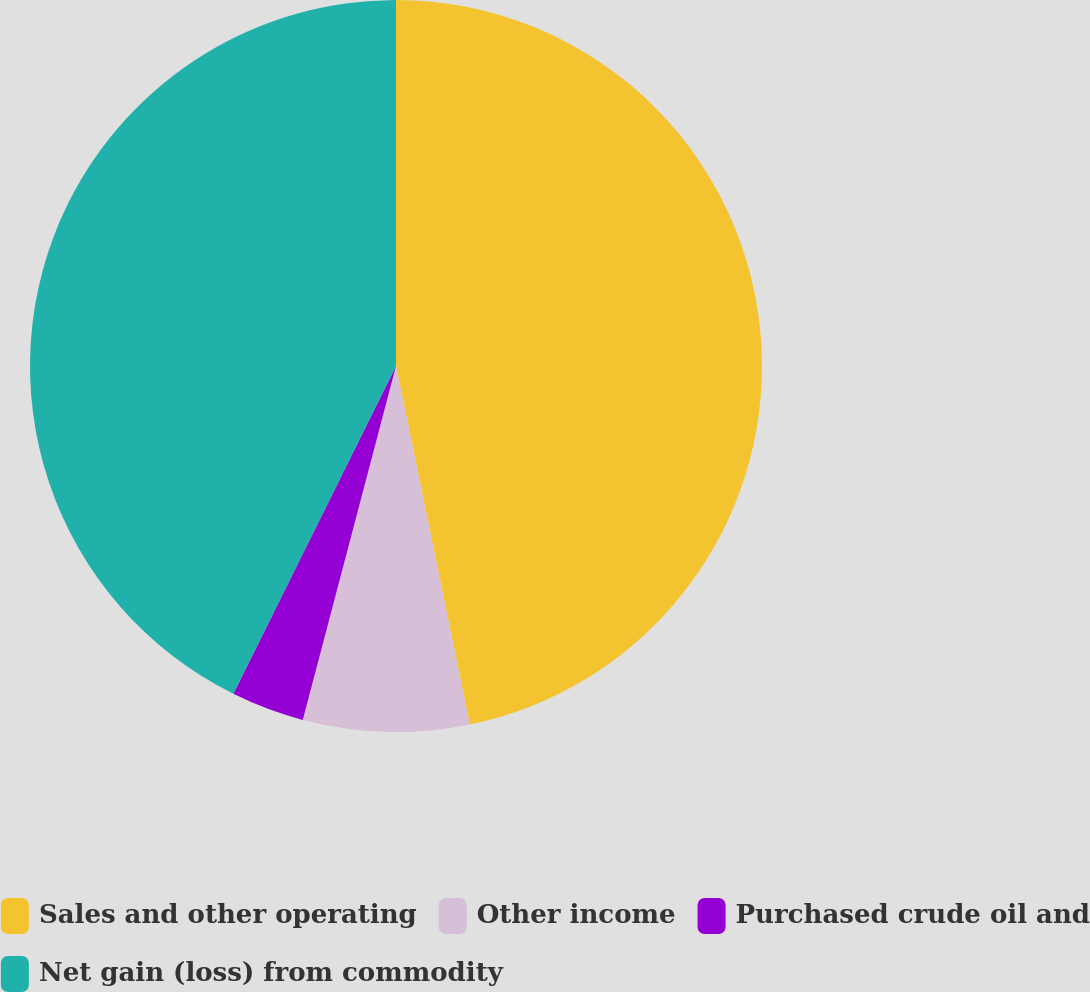Convert chart. <chart><loc_0><loc_0><loc_500><loc_500><pie_chart><fcel>Sales and other operating<fcel>Other income<fcel>Purchased crude oil and<fcel>Net gain (loss) from commodity<nl><fcel>46.77%<fcel>7.33%<fcel>3.23%<fcel>42.67%<nl></chart> 